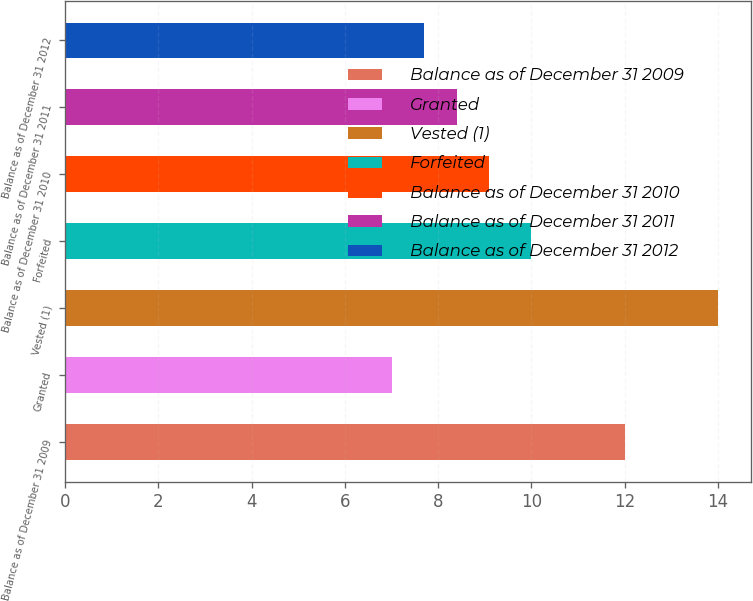Convert chart. <chart><loc_0><loc_0><loc_500><loc_500><bar_chart><fcel>Balance as of December 31 2009<fcel>Granted<fcel>Vested (1)<fcel>Forfeited<fcel>Balance as of December 31 2010<fcel>Balance as of December 31 2011<fcel>Balance as of December 31 2012<nl><fcel>12<fcel>7<fcel>14<fcel>10<fcel>9.1<fcel>8.4<fcel>7.7<nl></chart> 